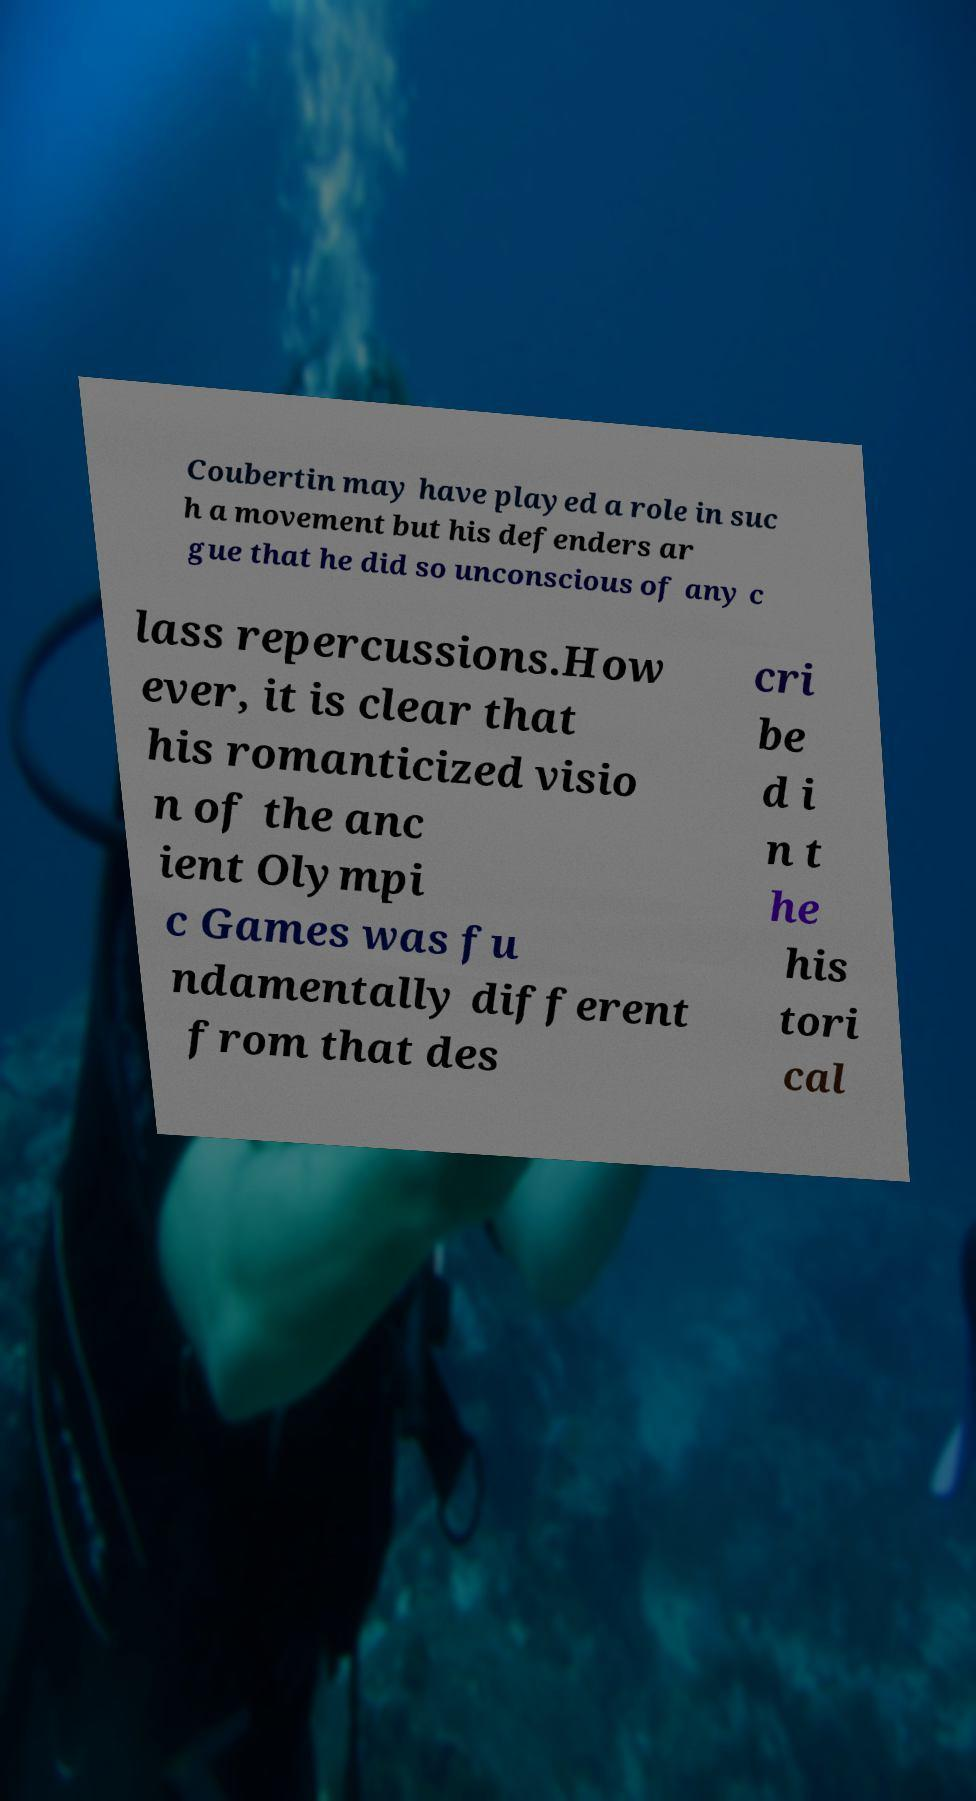Please identify and transcribe the text found in this image. Coubertin may have played a role in suc h a movement but his defenders ar gue that he did so unconscious of any c lass repercussions.How ever, it is clear that his romanticized visio n of the anc ient Olympi c Games was fu ndamentally different from that des cri be d i n t he his tori cal 